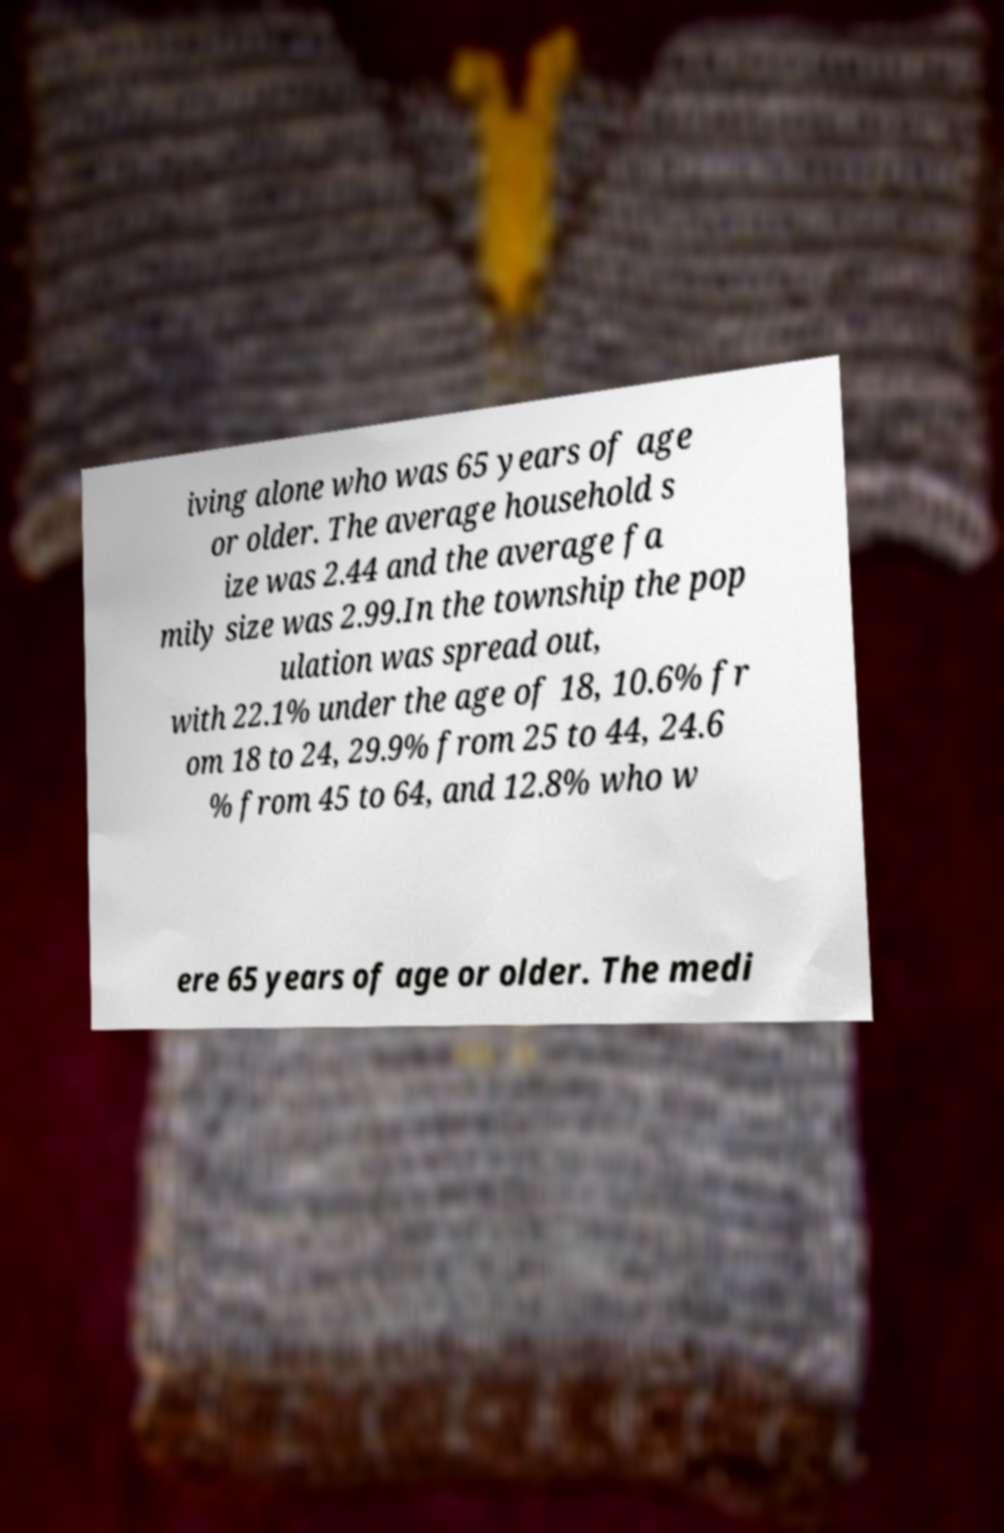Please read and relay the text visible in this image. What does it say? iving alone who was 65 years of age or older. The average household s ize was 2.44 and the average fa mily size was 2.99.In the township the pop ulation was spread out, with 22.1% under the age of 18, 10.6% fr om 18 to 24, 29.9% from 25 to 44, 24.6 % from 45 to 64, and 12.8% who w ere 65 years of age or older. The medi 